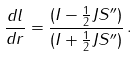Convert formula to latex. <formula><loc_0><loc_0><loc_500><loc_500>\frac { d l } { d r } = \frac { ( I - \frac { 1 } { 2 } J S ^ { \prime \prime } ) } { ( I + \frac { 1 } { 2 } J S ^ { \prime \prime } ) } \, .</formula> 